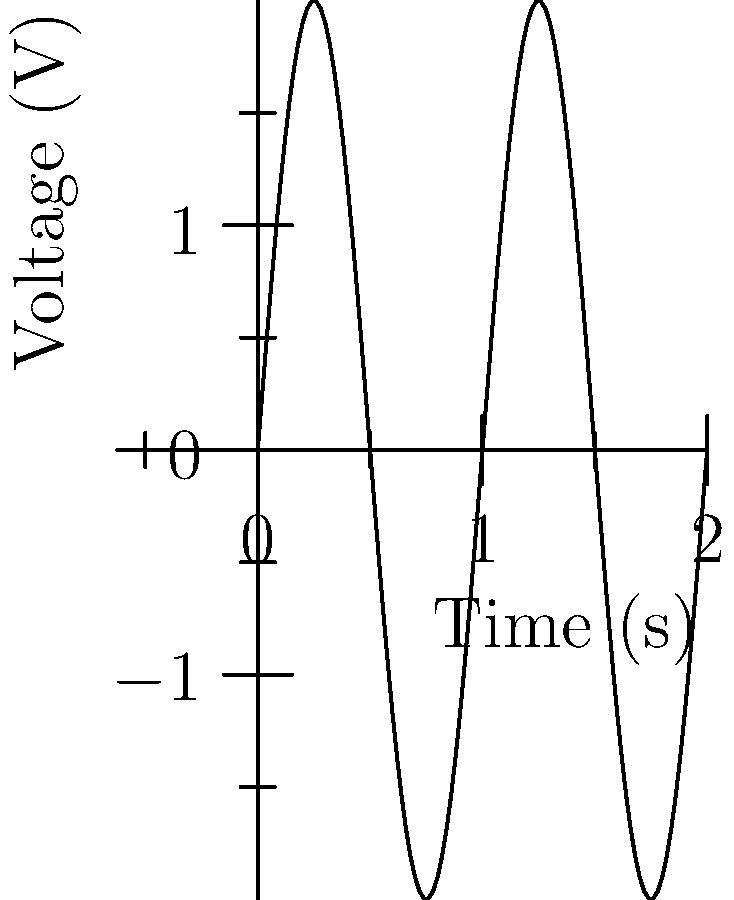As a news editor covering technological advancements, you encounter a waveform graph representing an electrical signal. The graph shows a sinusoidal wave with a peak-to-peak voltage of 4V and two complete cycles over a 2-second period. What is the frequency of this signal in Hertz (Hz)? To determine the frequency of the signal, we need to follow these steps:

1. Identify the number of complete cycles: The graph shows 2 complete cycles.

2. Determine the time period: The total time shown on the x-axis is 2 seconds.

3. Calculate the time for one complete cycle (T):
   $T = \frac{\text{Total time}}{\text{Number of cycles}} = \frac{2\text{ s}}{2} = 1\text{ s}$

4. Recall the relationship between frequency (f) and period (T):
   $f = \frac{1}{T}$

5. Calculate the frequency:
   $f = \frac{1}{T} = \frac{1}{1\text{ s}} = 1\text{ Hz}$

Therefore, the frequency of the signal is 1 Hz.
Answer: 1 Hz 